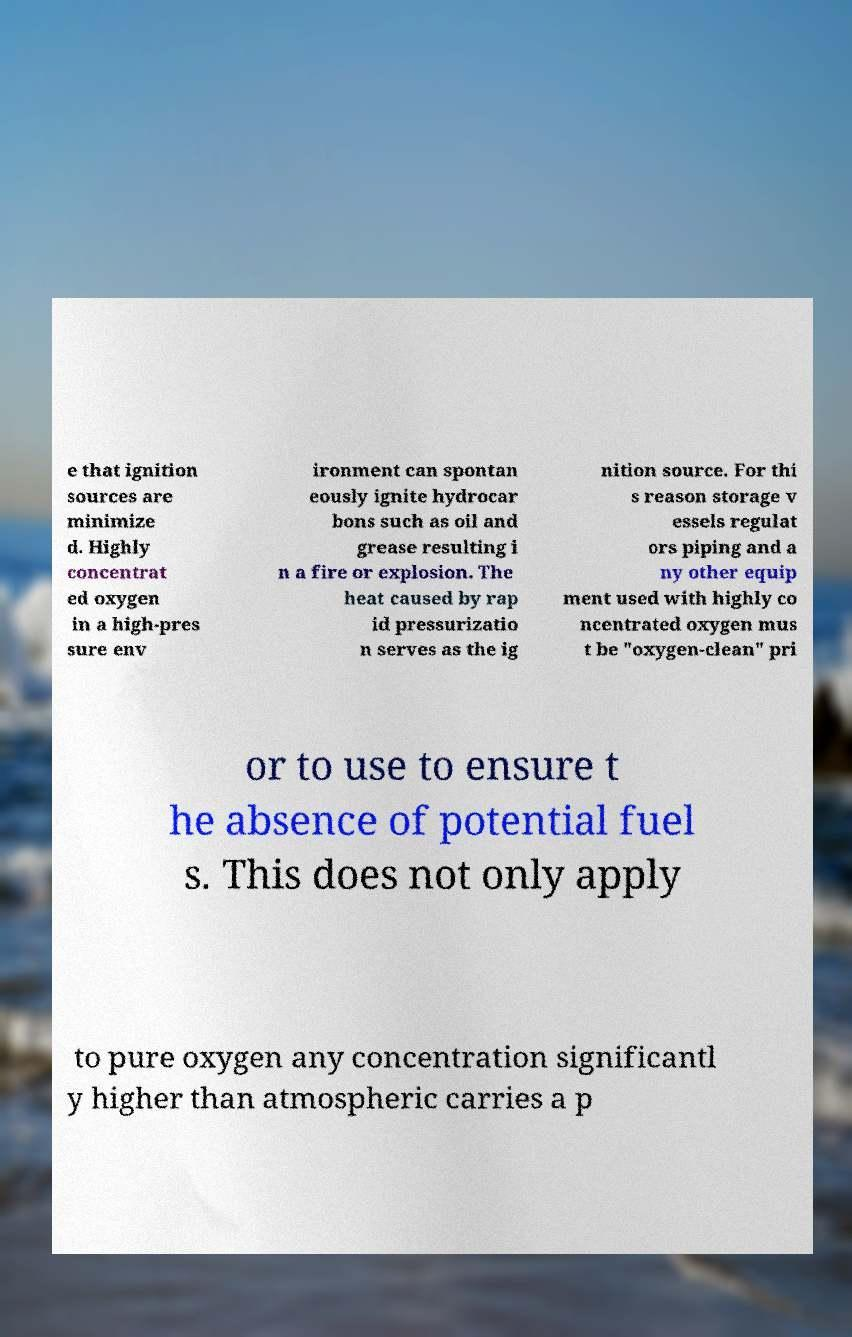There's text embedded in this image that I need extracted. Can you transcribe it verbatim? e that ignition sources are minimize d. Highly concentrat ed oxygen in a high-pres sure env ironment can spontan eously ignite hydrocar bons such as oil and grease resulting i n a fire or explosion. The heat caused by rap id pressurizatio n serves as the ig nition source. For thi s reason storage v essels regulat ors piping and a ny other equip ment used with highly co ncentrated oxygen mus t be "oxygen-clean" pri or to use to ensure t he absence of potential fuel s. This does not only apply to pure oxygen any concentration significantl y higher than atmospheric carries a p 